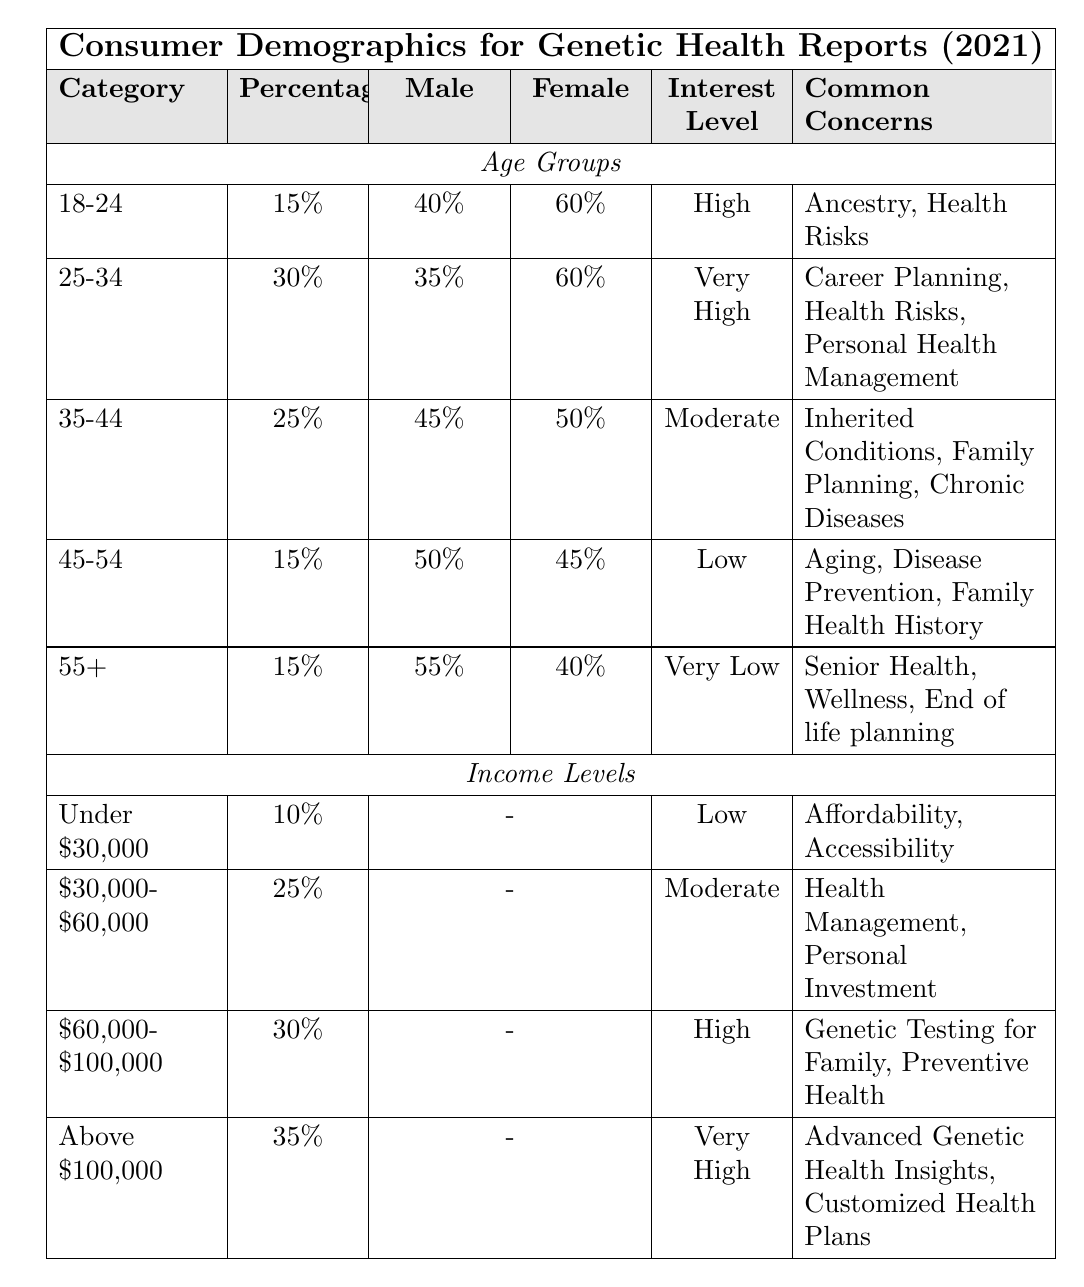What percentage of consumers aged 35-44 have a high interest level? According to the table, the age group 35-44 has an interest level marked as "Moderate," which does not equate to high. Thus, none of the consumers in that age group have a high interest level.
Answer: 0% What is the most common concern for consumers aged 25-34? The table lists the common concerns for the 25-34 age group as "Career Planning, Health Risks, Personal Health Management." Therefore, the most common concern is not specified as one single concern; it includes three.
Answer: Career Planning, Health Risks, Personal Health Management Which age group has the highest percentage of females interested in genetic health reports? For the table, the age group 18-24 has 60% female representation but is slightly less than those in the 25-34 age group, which also has females at 60%. Both age groups tie for the highest percentage.
Answer: 18-24 and 25-34 (60% each) Is the interest level for consumers earning above $100,000 very high? The data shows that the interest level for consumers in the income group above $100,000 is indeed rated as "Very High."
Answer: Yes What is the difference in percentage between the age group with the lowest interest level and the one with the highest? The age group 55+ has the lowest interest level categorized as "Very Low," with a percentage of 15%. The age group 25-34 has the highest interest level at 30%. The difference is 30% - 15% = 15%.
Answer: 15% Which income level has the highest percentage of interest and what is it paired with? The income level above $100,000 has the highest percentage at 35% paired with the "Very High" interest level.
Answer: 35% (Very High) What percentage of consumers in the 45-54 age group prioritize family health history? For the age group 45-54, “Family Health History” is one of the common concerns listed. However, the table does not provide a specific percentage for this concern alone; it is part of the group’s overall concerns.
Answer: Not specified What is the average percentage representation of male consumers across all age groups? We can calculate this by adding the male percentages from all age groups: 40% + 35% + 45% + 50% + 55% = 225%. There are 5 age groups, so the average is 225% / 5 = 45%.
Answer: 45% Which income level has the lowest common concern and what are they? The income level under $30,000 has the lowest percentage representation of 10% and cites common concerns of "Affordability, Accessibility."
Answer: Under $30,000: Affordability, Accessibility What can be inferred about the interest levels of younger age groups compared to older ones? From the table, younger groups (18-24 and 25-34) exhibit high or very high interest levels, while older age groups (45-54 and 55+) show low to very low interest levels. This suggests that younger consumers are significantly more interested in genetic health reports than older consumers.
Answer: Younger age groups are more interested than older ones 